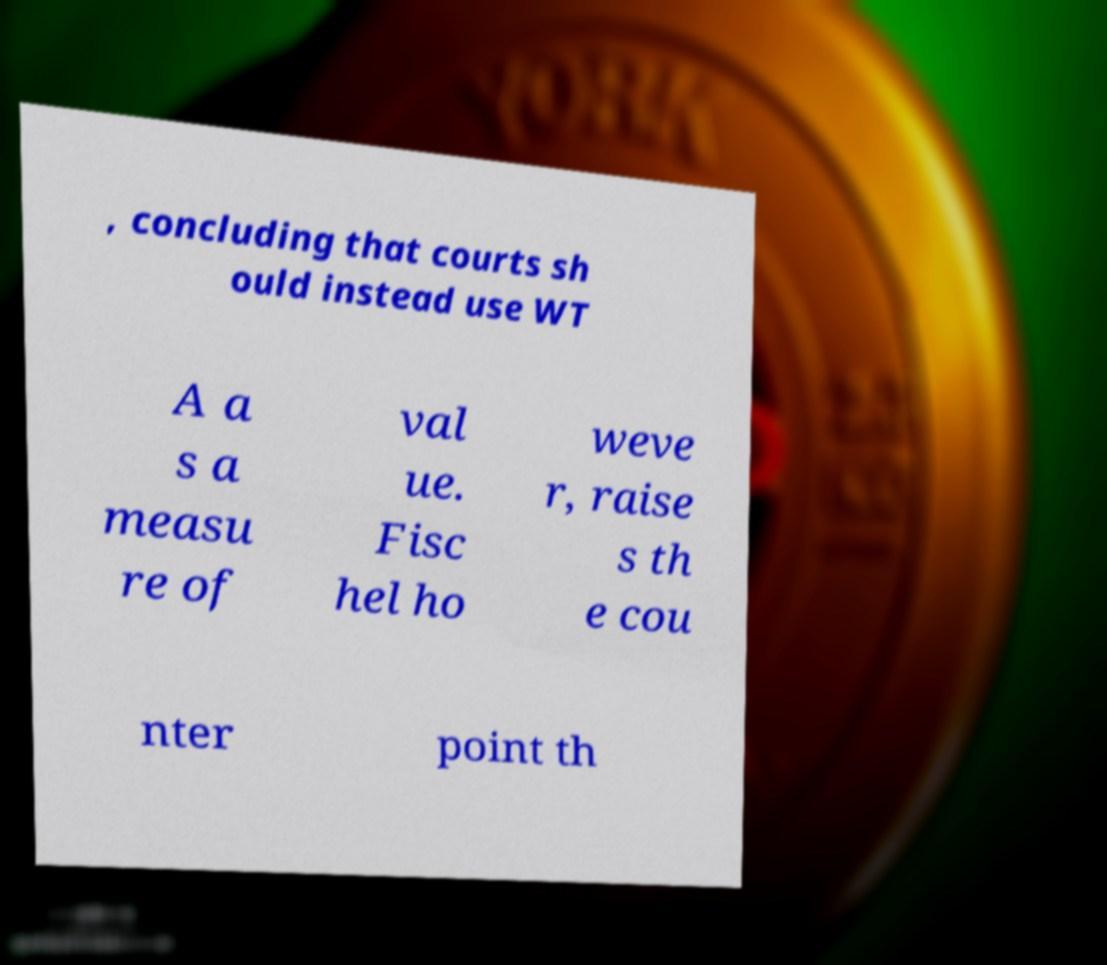Could you extract and type out the text from this image? , concluding that courts sh ould instead use WT A a s a measu re of val ue. Fisc hel ho weve r, raise s th e cou nter point th 